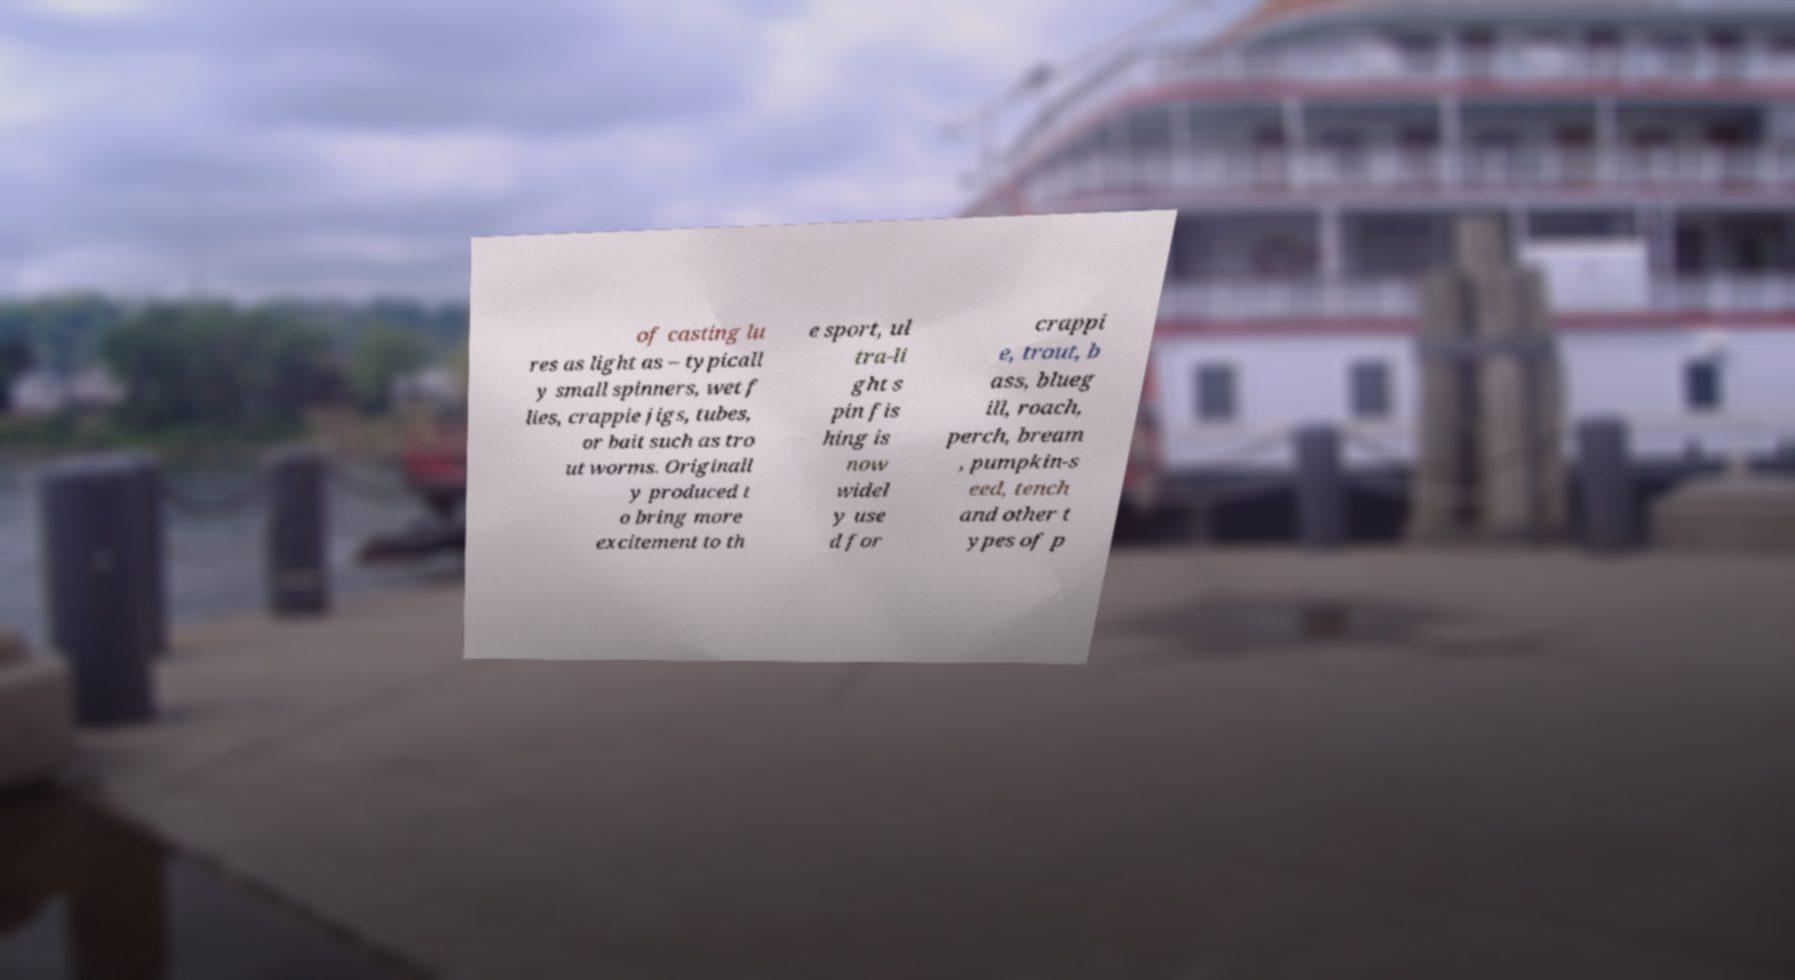Can you accurately transcribe the text from the provided image for me? of casting lu res as light as – typicall y small spinners, wet f lies, crappie jigs, tubes, or bait such as tro ut worms. Originall y produced t o bring more excitement to th e sport, ul tra-li ght s pin fis hing is now widel y use d for crappi e, trout, b ass, blueg ill, roach, perch, bream , pumpkin-s eed, tench and other t ypes of p 